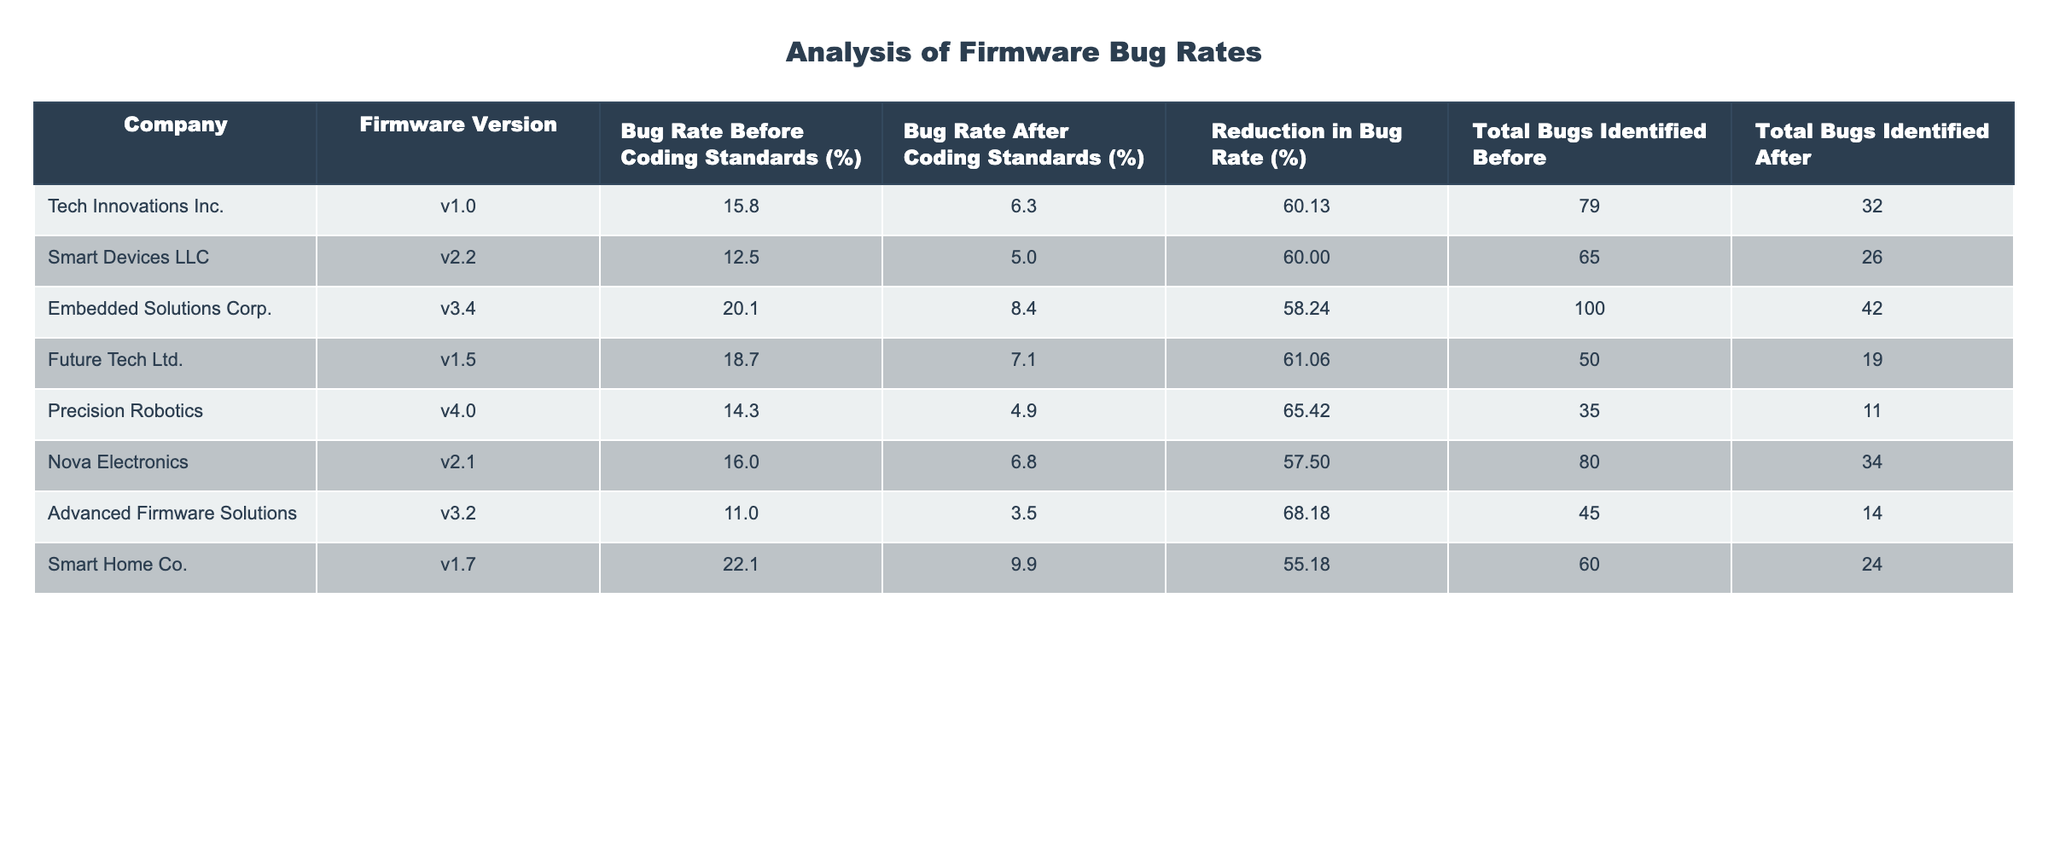What is the highest bug rate before coding standards among the companies? The table lists the bug rates before coding standards for each company. The highest value is 22.1%, corresponding to Smart Home Co.
Answer: 22.1% Which company achieved the lowest bug rate after implementing coding standards? The table shows that Advanced Firmware Solutions had the lowest bug rate after standards, at 3.5%.
Answer: 3.5% What is the average reduction in bug rate across all companies? To find the average reduction, we first sum the reductions: (60.13 + 60.00 + 58.24 + 61.06 + 65.42 + 57.50 + 68.18 + 55.18) = 445.71. Then, divide by the number of companies (8) to find the average: 445.71 / 8 ≈ 55.71%.
Answer: 55.71% Is it true that all companies reduced their bug rates by more than 50%? A check of the reduction percentages shows that all companies did indeed have reductions exceeding 50%, with the lowest being 55.18% for Smart Home Co.
Answer: Yes Which company's bug rate after coding standards is closer to the average bug rate before coding standards? The average bug rate before standards is (15.8 + 12.5 + 20.1 + 18.7 + 14.3 + 16.0 + 11.0 + 22.1) / 8 = 16.3%. Comparing to each company's bug rate after standards, the closest is Smart Devices LLC at 5.0% since it is the lowest after standards, making the difference significant but large in relation to the average before.
Answer: Smart Devices LLC What is the total number of bugs identified after the implementation of coding standards? By summing the total bugs identified after for each company: (32 + 26 + 42 + 19 + 11 + 34 + 14 + 24) = 262.
Answer: 262 How many companies had a bug rate before coding standards greater than 15%? Checking the table, the companies with a bug rate greater than 15% before standards are Tech Innovations Inc., Embedded Solutions Corp., Future Tech Ltd., Smart Home Co., and Nova Electronics, making a total of 5 companies.
Answer: 5 Which company showed the most significant improvement in bug rate? To find out, we can look at the reduction in bug rates: Precision Robotics, which had a reduction of 65.42%, is the most significant improvement in bug rate compared to others.
Answer: Precision Robotics 